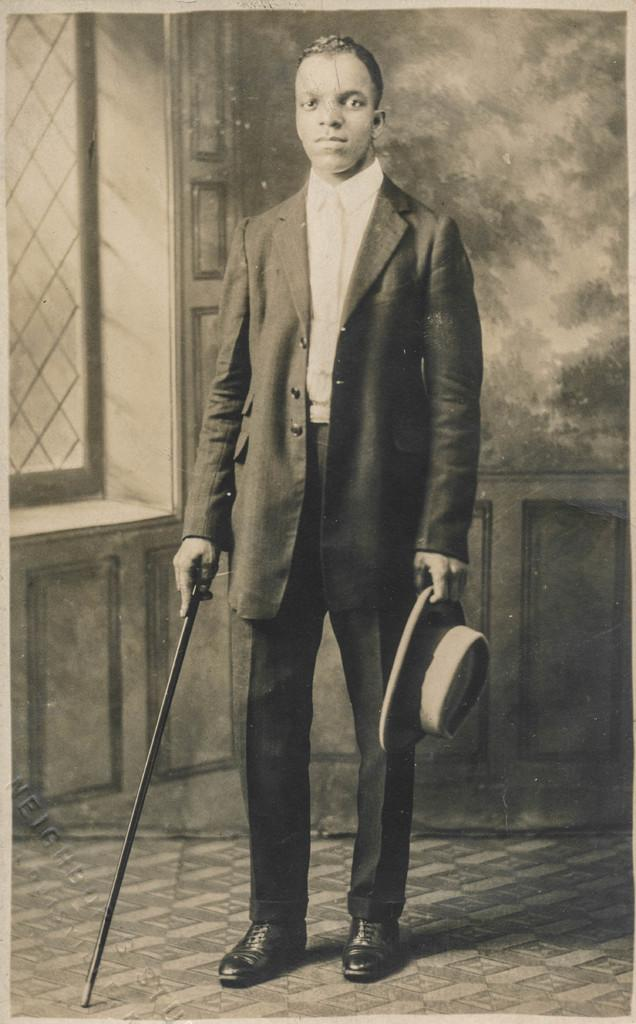Who is the main subject in the image? There is a man in the image. Where is the man positioned in the image? The man is standing in the center of the image. What is the man holding in his hand? The man is holding a black stick in his hand. What is the man wearing on his head? The man is holding a hat. What can be seen in the background of the image? There is a window and a wall in the background of the image. What type of pie is the man eating in the image? There is no pie present in the image; the man is holding a black stick and a hat. 